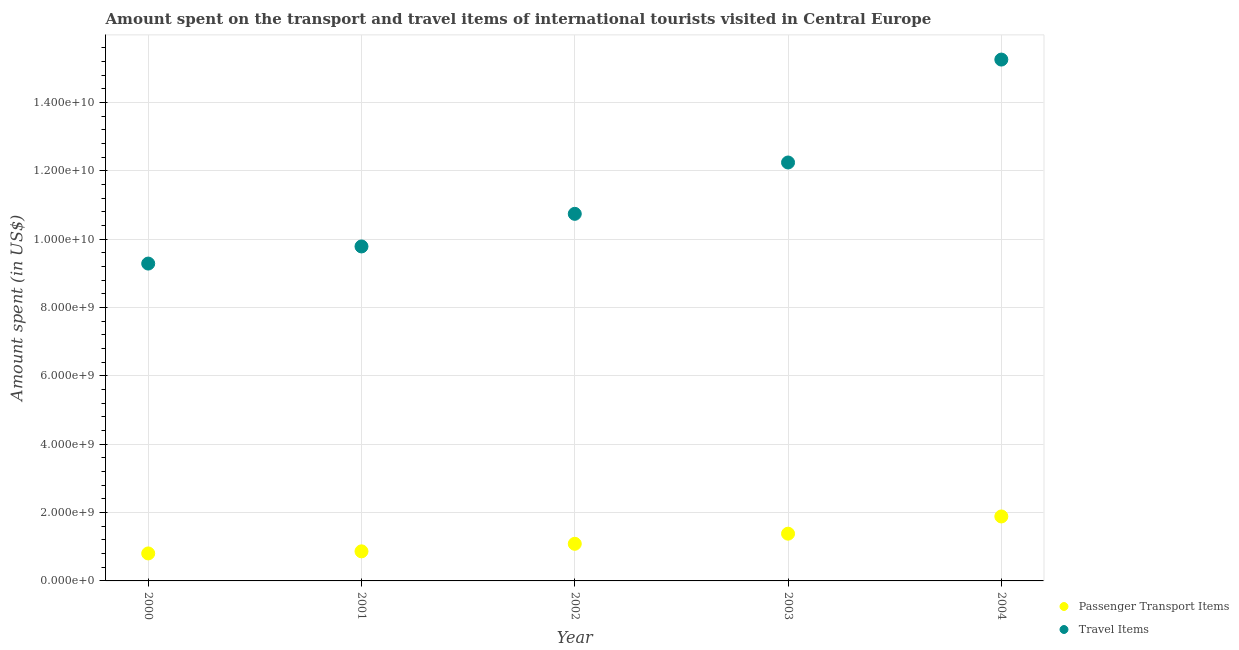What is the amount spent on passenger transport items in 2002?
Provide a succinct answer. 1.09e+09. Across all years, what is the maximum amount spent in travel items?
Make the answer very short. 1.53e+1. Across all years, what is the minimum amount spent in travel items?
Keep it short and to the point. 9.28e+09. In which year was the amount spent on passenger transport items maximum?
Your response must be concise. 2004. What is the total amount spent on passenger transport items in the graph?
Provide a succinct answer. 6.02e+09. What is the difference between the amount spent in travel items in 2002 and that in 2004?
Your answer should be compact. -4.51e+09. What is the difference between the amount spent in travel items in 2000 and the amount spent on passenger transport items in 2004?
Make the answer very short. 7.40e+09. What is the average amount spent in travel items per year?
Your answer should be compact. 1.15e+1. In the year 2000, what is the difference between the amount spent in travel items and amount spent on passenger transport items?
Make the answer very short. 8.48e+09. In how many years, is the amount spent in travel items greater than 5600000000 US$?
Give a very brief answer. 5. What is the ratio of the amount spent in travel items in 2002 to that in 2004?
Offer a terse response. 0.7. Is the amount spent in travel items in 2001 less than that in 2003?
Your answer should be very brief. Yes. Is the difference between the amount spent in travel items in 2003 and 2004 greater than the difference between the amount spent on passenger transport items in 2003 and 2004?
Provide a succinct answer. No. What is the difference between the highest and the second highest amount spent in travel items?
Give a very brief answer. 3.01e+09. What is the difference between the highest and the lowest amount spent in travel items?
Provide a short and direct response. 5.97e+09. Does the amount spent on passenger transport items monotonically increase over the years?
Give a very brief answer. Yes. Is the amount spent on passenger transport items strictly less than the amount spent in travel items over the years?
Provide a succinct answer. Yes. What is the difference between two consecutive major ticks on the Y-axis?
Keep it short and to the point. 2.00e+09. Does the graph contain any zero values?
Your answer should be very brief. No. Where does the legend appear in the graph?
Make the answer very short. Bottom right. How are the legend labels stacked?
Keep it short and to the point. Vertical. What is the title of the graph?
Provide a short and direct response. Amount spent on the transport and travel items of international tourists visited in Central Europe. What is the label or title of the Y-axis?
Provide a short and direct response. Amount spent (in US$). What is the Amount spent (in US$) in Passenger Transport Items in 2000?
Your answer should be very brief. 8.04e+08. What is the Amount spent (in US$) in Travel Items in 2000?
Keep it short and to the point. 9.28e+09. What is the Amount spent (in US$) in Passenger Transport Items in 2001?
Keep it short and to the point. 8.65e+08. What is the Amount spent (in US$) of Travel Items in 2001?
Your answer should be compact. 9.78e+09. What is the Amount spent (in US$) of Passenger Transport Items in 2002?
Make the answer very short. 1.09e+09. What is the Amount spent (in US$) in Travel Items in 2002?
Make the answer very short. 1.07e+1. What is the Amount spent (in US$) in Passenger Transport Items in 2003?
Keep it short and to the point. 1.38e+09. What is the Amount spent (in US$) of Travel Items in 2003?
Offer a very short reply. 1.22e+1. What is the Amount spent (in US$) in Passenger Transport Items in 2004?
Make the answer very short. 1.89e+09. What is the Amount spent (in US$) in Travel Items in 2004?
Make the answer very short. 1.53e+1. Across all years, what is the maximum Amount spent (in US$) in Passenger Transport Items?
Your answer should be compact. 1.89e+09. Across all years, what is the maximum Amount spent (in US$) in Travel Items?
Provide a succinct answer. 1.53e+1. Across all years, what is the minimum Amount spent (in US$) of Passenger Transport Items?
Your answer should be compact. 8.04e+08. Across all years, what is the minimum Amount spent (in US$) of Travel Items?
Your response must be concise. 9.28e+09. What is the total Amount spent (in US$) in Passenger Transport Items in the graph?
Provide a short and direct response. 6.02e+09. What is the total Amount spent (in US$) in Travel Items in the graph?
Make the answer very short. 5.73e+1. What is the difference between the Amount spent (in US$) in Passenger Transport Items in 2000 and that in 2001?
Give a very brief answer. -6.13e+07. What is the difference between the Amount spent (in US$) of Travel Items in 2000 and that in 2001?
Provide a succinct answer. -5.01e+08. What is the difference between the Amount spent (in US$) of Passenger Transport Items in 2000 and that in 2002?
Offer a terse response. -2.82e+08. What is the difference between the Amount spent (in US$) in Travel Items in 2000 and that in 2002?
Keep it short and to the point. -1.46e+09. What is the difference between the Amount spent (in US$) of Passenger Transport Items in 2000 and that in 2003?
Offer a very short reply. -5.78e+08. What is the difference between the Amount spent (in US$) in Travel Items in 2000 and that in 2003?
Offer a very short reply. -2.96e+09. What is the difference between the Amount spent (in US$) in Passenger Transport Items in 2000 and that in 2004?
Keep it short and to the point. -1.08e+09. What is the difference between the Amount spent (in US$) in Travel Items in 2000 and that in 2004?
Offer a terse response. -5.97e+09. What is the difference between the Amount spent (in US$) in Passenger Transport Items in 2001 and that in 2002?
Your response must be concise. -2.21e+08. What is the difference between the Amount spent (in US$) in Travel Items in 2001 and that in 2002?
Your answer should be very brief. -9.54e+08. What is the difference between the Amount spent (in US$) of Passenger Transport Items in 2001 and that in 2003?
Ensure brevity in your answer.  -5.17e+08. What is the difference between the Amount spent (in US$) in Travel Items in 2001 and that in 2003?
Make the answer very short. -2.46e+09. What is the difference between the Amount spent (in US$) in Passenger Transport Items in 2001 and that in 2004?
Offer a terse response. -1.02e+09. What is the difference between the Amount spent (in US$) in Travel Items in 2001 and that in 2004?
Ensure brevity in your answer.  -5.47e+09. What is the difference between the Amount spent (in US$) in Passenger Transport Items in 2002 and that in 2003?
Your answer should be compact. -2.96e+08. What is the difference between the Amount spent (in US$) in Travel Items in 2002 and that in 2003?
Offer a very short reply. -1.50e+09. What is the difference between the Amount spent (in US$) in Passenger Transport Items in 2002 and that in 2004?
Ensure brevity in your answer.  -8.00e+08. What is the difference between the Amount spent (in US$) of Travel Items in 2002 and that in 2004?
Keep it short and to the point. -4.51e+09. What is the difference between the Amount spent (in US$) in Passenger Transport Items in 2003 and that in 2004?
Give a very brief answer. -5.04e+08. What is the difference between the Amount spent (in US$) in Travel Items in 2003 and that in 2004?
Your response must be concise. -3.01e+09. What is the difference between the Amount spent (in US$) of Passenger Transport Items in 2000 and the Amount spent (in US$) of Travel Items in 2001?
Offer a terse response. -8.98e+09. What is the difference between the Amount spent (in US$) in Passenger Transport Items in 2000 and the Amount spent (in US$) in Travel Items in 2002?
Offer a very short reply. -9.93e+09. What is the difference between the Amount spent (in US$) of Passenger Transport Items in 2000 and the Amount spent (in US$) of Travel Items in 2003?
Offer a terse response. -1.14e+1. What is the difference between the Amount spent (in US$) of Passenger Transport Items in 2000 and the Amount spent (in US$) of Travel Items in 2004?
Make the answer very short. -1.44e+1. What is the difference between the Amount spent (in US$) in Passenger Transport Items in 2001 and the Amount spent (in US$) in Travel Items in 2002?
Give a very brief answer. -9.87e+09. What is the difference between the Amount spent (in US$) of Passenger Transport Items in 2001 and the Amount spent (in US$) of Travel Items in 2003?
Offer a very short reply. -1.14e+1. What is the difference between the Amount spent (in US$) in Passenger Transport Items in 2001 and the Amount spent (in US$) in Travel Items in 2004?
Ensure brevity in your answer.  -1.44e+1. What is the difference between the Amount spent (in US$) of Passenger Transport Items in 2002 and the Amount spent (in US$) of Travel Items in 2003?
Offer a very short reply. -1.12e+1. What is the difference between the Amount spent (in US$) in Passenger Transport Items in 2002 and the Amount spent (in US$) in Travel Items in 2004?
Make the answer very short. -1.42e+1. What is the difference between the Amount spent (in US$) of Passenger Transport Items in 2003 and the Amount spent (in US$) of Travel Items in 2004?
Offer a very short reply. -1.39e+1. What is the average Amount spent (in US$) of Passenger Transport Items per year?
Give a very brief answer. 1.20e+09. What is the average Amount spent (in US$) in Travel Items per year?
Keep it short and to the point. 1.15e+1. In the year 2000, what is the difference between the Amount spent (in US$) in Passenger Transport Items and Amount spent (in US$) in Travel Items?
Offer a very short reply. -8.48e+09. In the year 2001, what is the difference between the Amount spent (in US$) of Passenger Transport Items and Amount spent (in US$) of Travel Items?
Your response must be concise. -8.92e+09. In the year 2002, what is the difference between the Amount spent (in US$) in Passenger Transport Items and Amount spent (in US$) in Travel Items?
Provide a short and direct response. -9.65e+09. In the year 2003, what is the difference between the Amount spent (in US$) in Passenger Transport Items and Amount spent (in US$) in Travel Items?
Your answer should be very brief. -1.09e+1. In the year 2004, what is the difference between the Amount spent (in US$) in Passenger Transport Items and Amount spent (in US$) in Travel Items?
Your response must be concise. -1.34e+1. What is the ratio of the Amount spent (in US$) of Passenger Transport Items in 2000 to that in 2001?
Provide a succinct answer. 0.93. What is the ratio of the Amount spent (in US$) of Travel Items in 2000 to that in 2001?
Offer a terse response. 0.95. What is the ratio of the Amount spent (in US$) in Passenger Transport Items in 2000 to that in 2002?
Your answer should be compact. 0.74. What is the ratio of the Amount spent (in US$) of Travel Items in 2000 to that in 2002?
Your response must be concise. 0.86. What is the ratio of the Amount spent (in US$) of Passenger Transport Items in 2000 to that in 2003?
Make the answer very short. 0.58. What is the ratio of the Amount spent (in US$) of Travel Items in 2000 to that in 2003?
Give a very brief answer. 0.76. What is the ratio of the Amount spent (in US$) in Passenger Transport Items in 2000 to that in 2004?
Offer a terse response. 0.43. What is the ratio of the Amount spent (in US$) of Travel Items in 2000 to that in 2004?
Provide a short and direct response. 0.61. What is the ratio of the Amount spent (in US$) in Passenger Transport Items in 2001 to that in 2002?
Your response must be concise. 0.8. What is the ratio of the Amount spent (in US$) in Travel Items in 2001 to that in 2002?
Offer a terse response. 0.91. What is the ratio of the Amount spent (in US$) of Passenger Transport Items in 2001 to that in 2003?
Provide a short and direct response. 0.63. What is the ratio of the Amount spent (in US$) of Travel Items in 2001 to that in 2003?
Make the answer very short. 0.8. What is the ratio of the Amount spent (in US$) in Passenger Transport Items in 2001 to that in 2004?
Give a very brief answer. 0.46. What is the ratio of the Amount spent (in US$) of Travel Items in 2001 to that in 2004?
Your answer should be very brief. 0.64. What is the ratio of the Amount spent (in US$) of Passenger Transport Items in 2002 to that in 2003?
Offer a terse response. 0.79. What is the ratio of the Amount spent (in US$) of Travel Items in 2002 to that in 2003?
Give a very brief answer. 0.88. What is the ratio of the Amount spent (in US$) of Passenger Transport Items in 2002 to that in 2004?
Provide a short and direct response. 0.58. What is the ratio of the Amount spent (in US$) in Travel Items in 2002 to that in 2004?
Provide a succinct answer. 0.7. What is the ratio of the Amount spent (in US$) in Passenger Transport Items in 2003 to that in 2004?
Provide a short and direct response. 0.73. What is the ratio of the Amount spent (in US$) in Travel Items in 2003 to that in 2004?
Offer a very short reply. 0.8. What is the difference between the highest and the second highest Amount spent (in US$) of Passenger Transport Items?
Provide a short and direct response. 5.04e+08. What is the difference between the highest and the second highest Amount spent (in US$) in Travel Items?
Offer a terse response. 3.01e+09. What is the difference between the highest and the lowest Amount spent (in US$) in Passenger Transport Items?
Your answer should be very brief. 1.08e+09. What is the difference between the highest and the lowest Amount spent (in US$) in Travel Items?
Provide a short and direct response. 5.97e+09. 